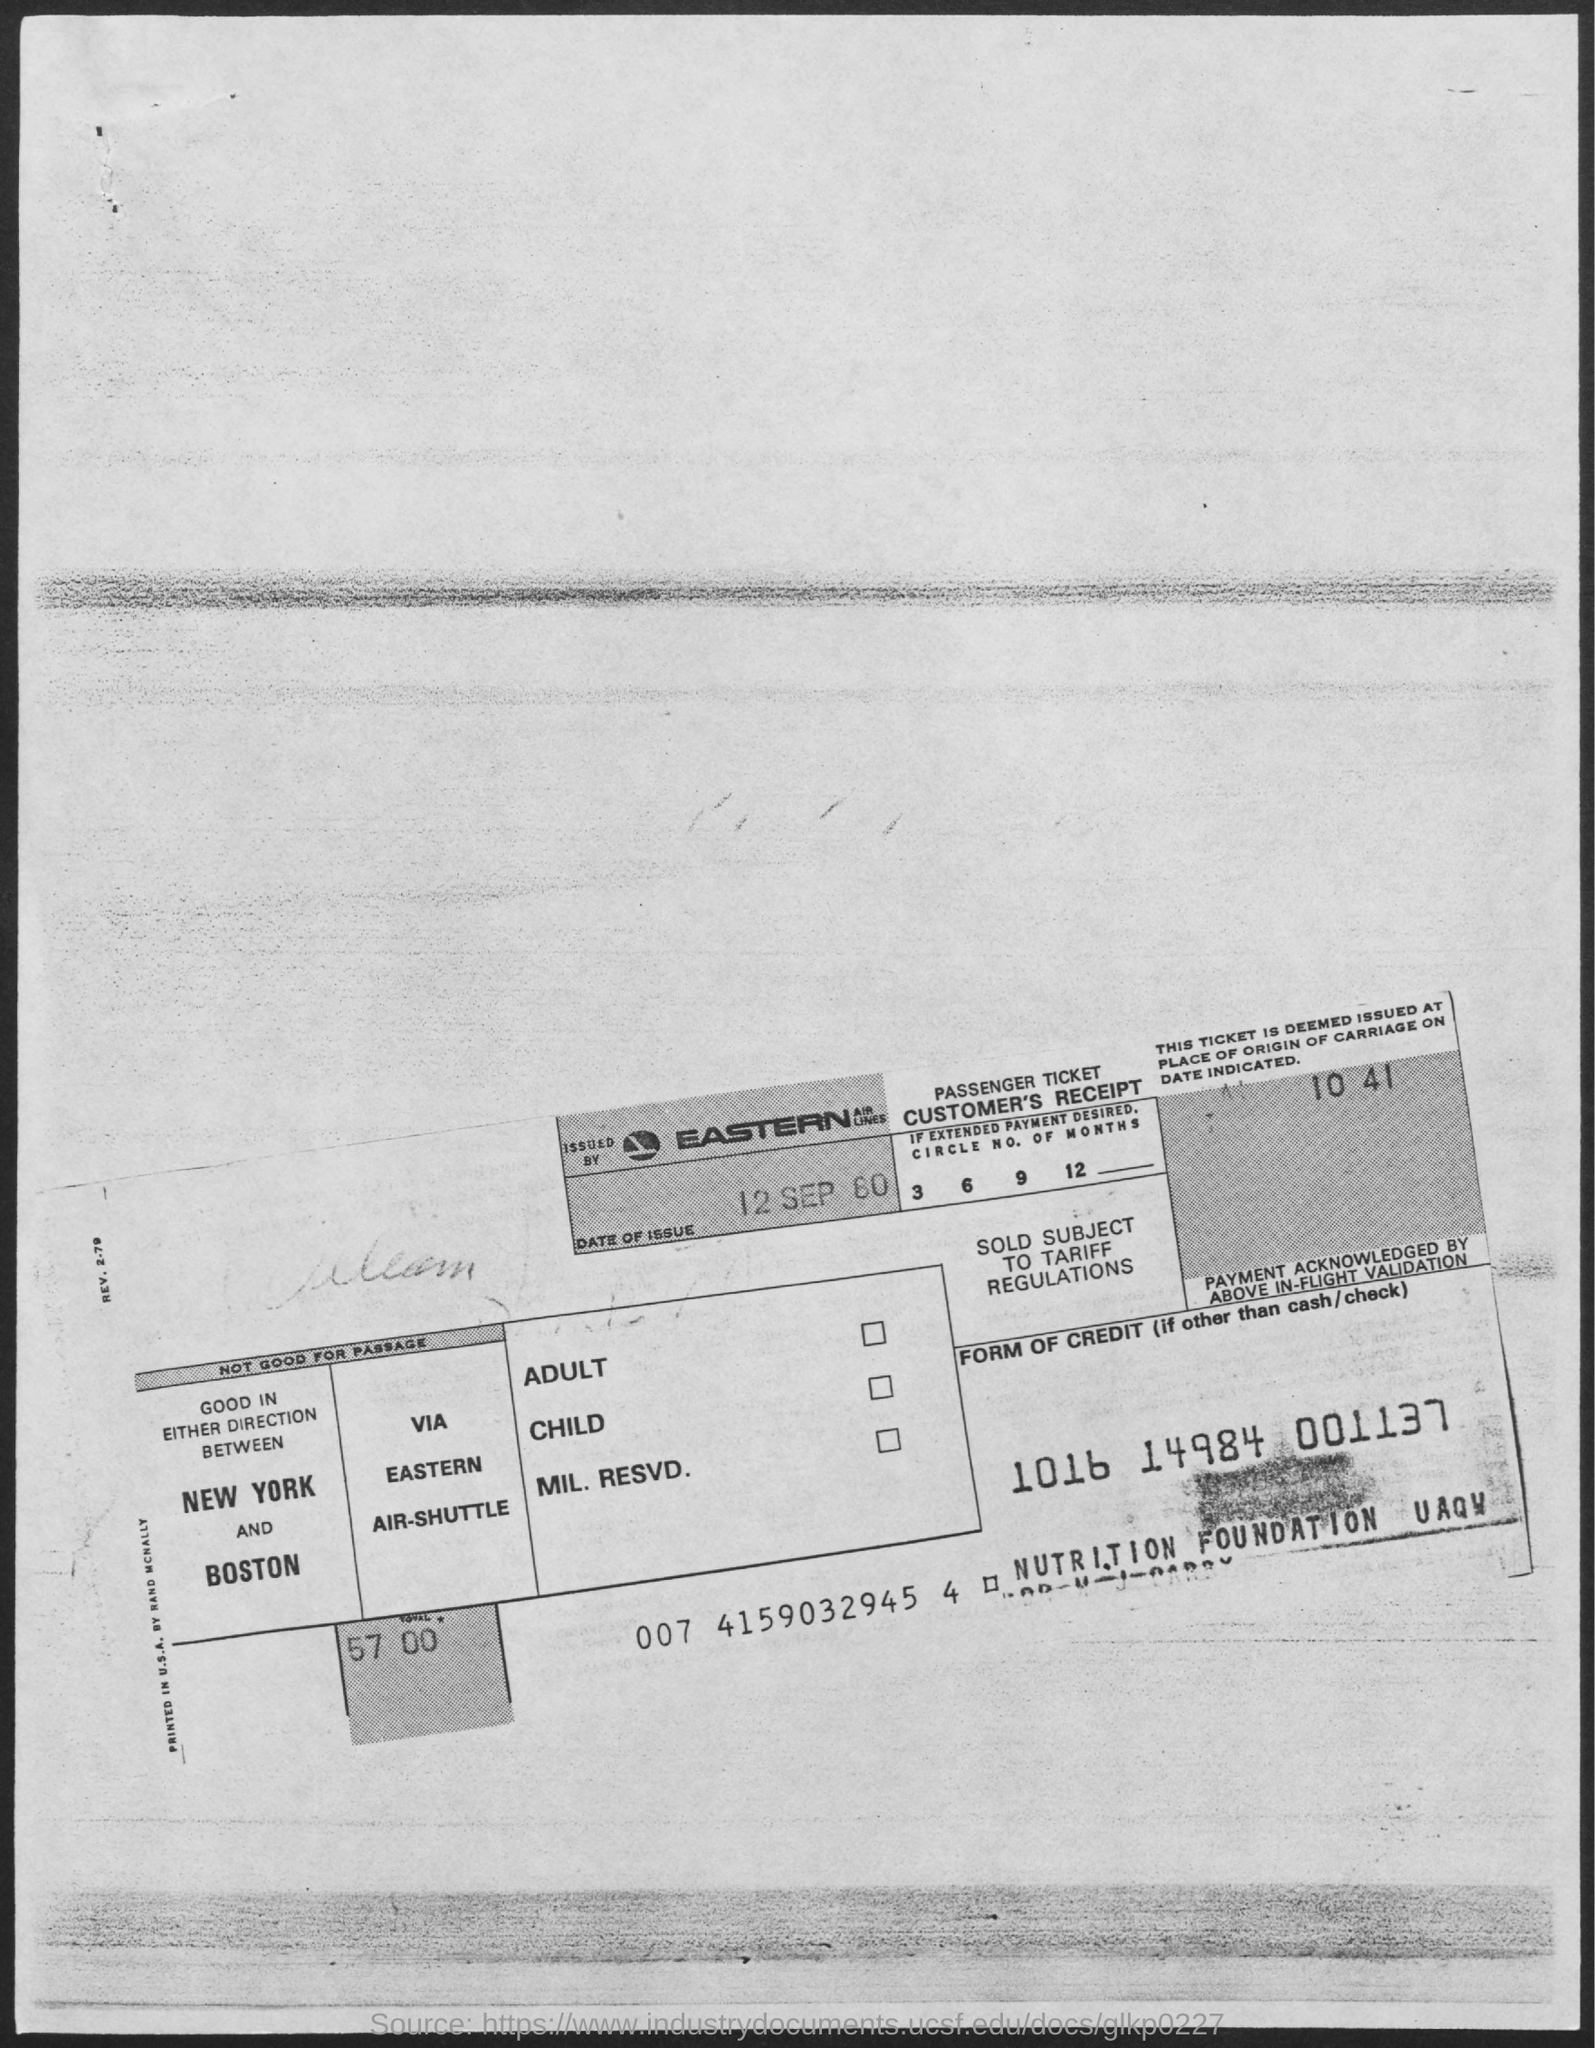Indicate a few pertinent items in this graphic. The total amount is 57,000. The ticket is issued by Eastern Airlines. 